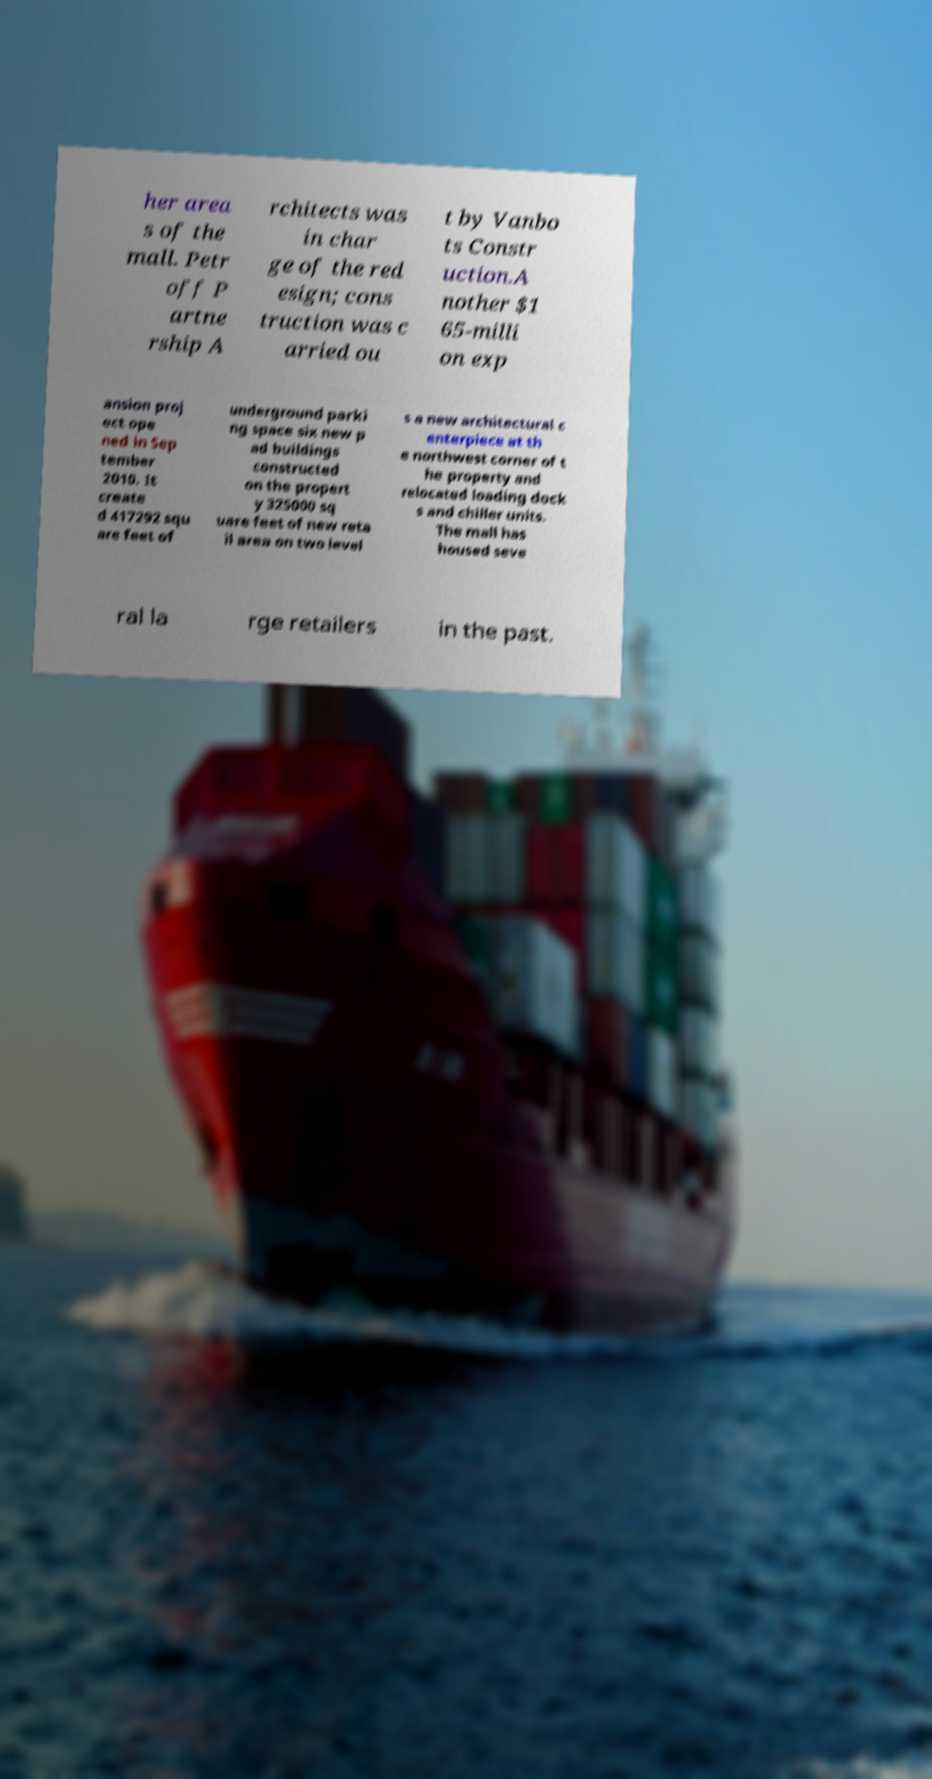Please read and relay the text visible in this image. What does it say? her area s of the mall. Petr off P artne rship A rchitects was in char ge of the red esign; cons truction was c arried ou t by Vanbo ts Constr uction.A nother $1 65-milli on exp ansion proj ect ope ned in Sep tember 2010. It create d 417292 squ are feet of underground parki ng space six new p ad buildings constructed on the propert y 325000 sq uare feet of new reta il area on two level s a new architectural c enterpiece at th e northwest corner of t he property and relocated loading dock s and chiller units. The mall has housed seve ral la rge retailers in the past. 